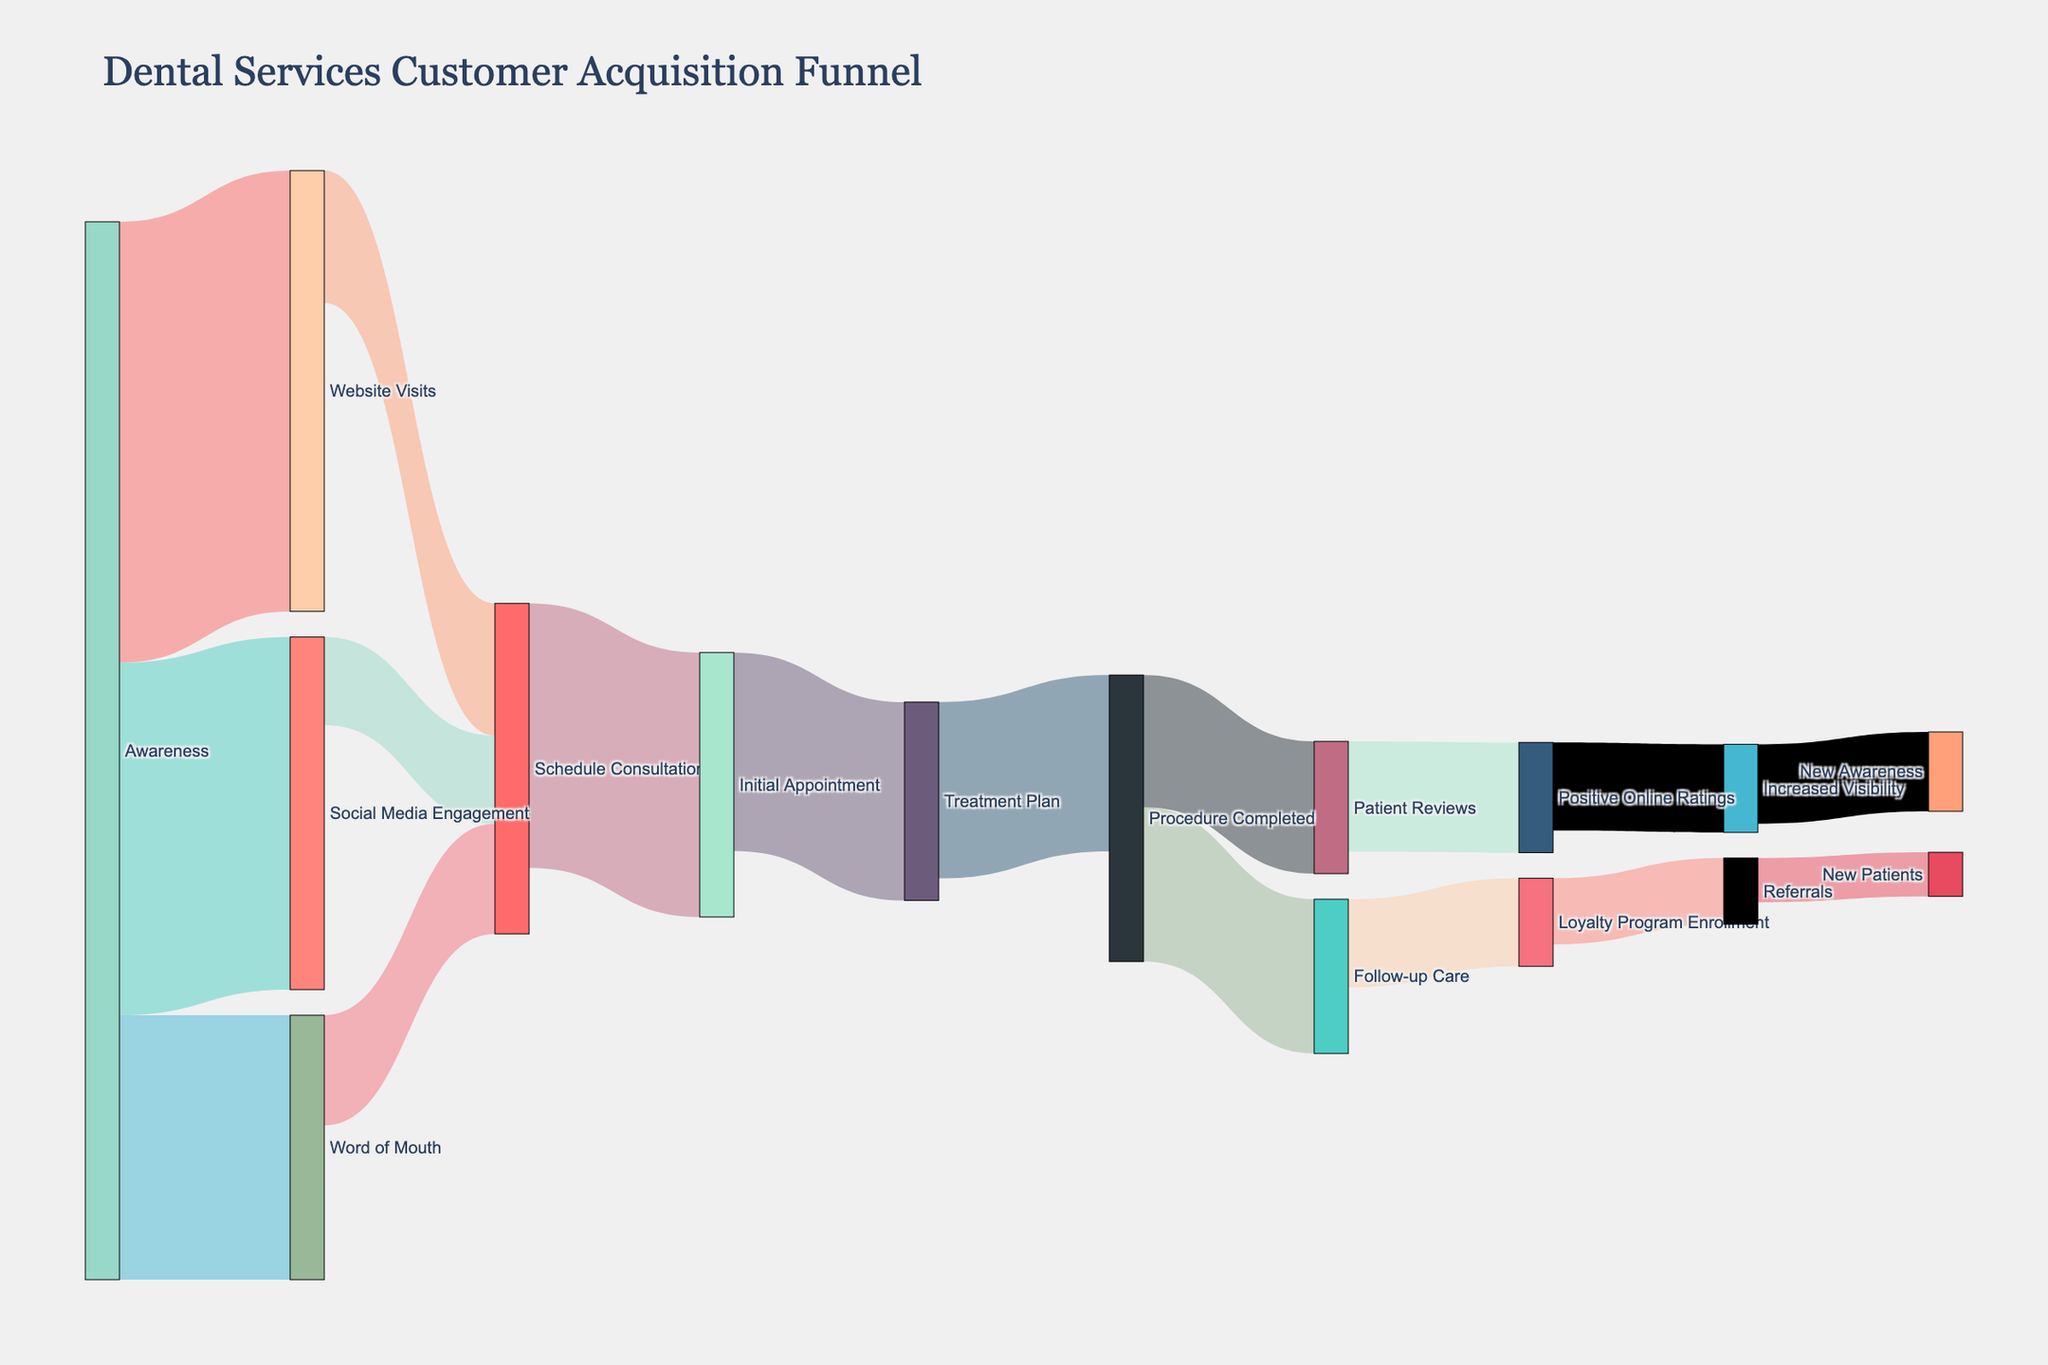What is the title of the Sankey diagram? The title is displayed at the top of the diagram and provides an overview of what the illustration is about.
Answer: Dental Services Customer Acquisition Funnel How many sources lead to "Schedule Consultation"? By observing the diagram, you can see that three pathways lead to "Schedule Consultation" from "Website Visits," "Social Media Engagement," and "Word of Mouth."
Answer: 3 What is the total flow value from "Awareness" to all its targets? Sum the values of all paths stemming from "Awareness": 1000 (Website Visits) + 800 (Social Media Engagement) + 600 (Word of Mouth) = 2400.
Answer: 2400 Which stage has the highest single flow value and, what is it? Comparing flow values, the highest value is from "Awareness" to "Website Visits" which is 1000.
Answer: Awareness to Website Visits: 1000 What is the total number of new patients acquired through the referrals program? The final value leading to "New Patients" from "Referrals" is shown as 100 in the diagram.
Answer: 100 How many unique stages are represented in the Sankey diagram? Count all unique nodes (stages) listed in the diagram: Awareness, Website Visits, Social Media Engagement, Word of Mouth, Schedule Consultation, Initial Appointment, Treatment Plan, Procedure Completed, Follow-up Care, Loyalty Program Enrollment, Referrals, New Patients, Patient Reviews, Positive Online Ratings, Increased Visibility, New Awareness.
Answer: 15 How many patients complete the procedure but do not enroll in the loyalty program? To find, subtract the value flowing to "Loyalty Program Enrollment" from "Procedure Completed": 400 (Procedure Completed) - 200 (Loyalty Program Enrollment) = 200.
Answer: 200 Which stage has the most connections leading into it? By visual inspection, "Schedule Consultation" has three incoming flows from "Website Visits," "Social Media Engagement," and "Word of Mouth," which is the highest.
Answer: Schedule Consultation How many patients move from "Procedure Completed" to "Patient Reviews"? The flow value from "Procedure Completed" to "Patient Reviews" is specifically labeled as 300 in the diagram.
Answer: 300 What is the final value leading to "Increased Visibility"? Check the flow path and value leading to "Increased Visibility," which comes from "Positive Online Ratings" and is labeled as 200.
Answer: 200 